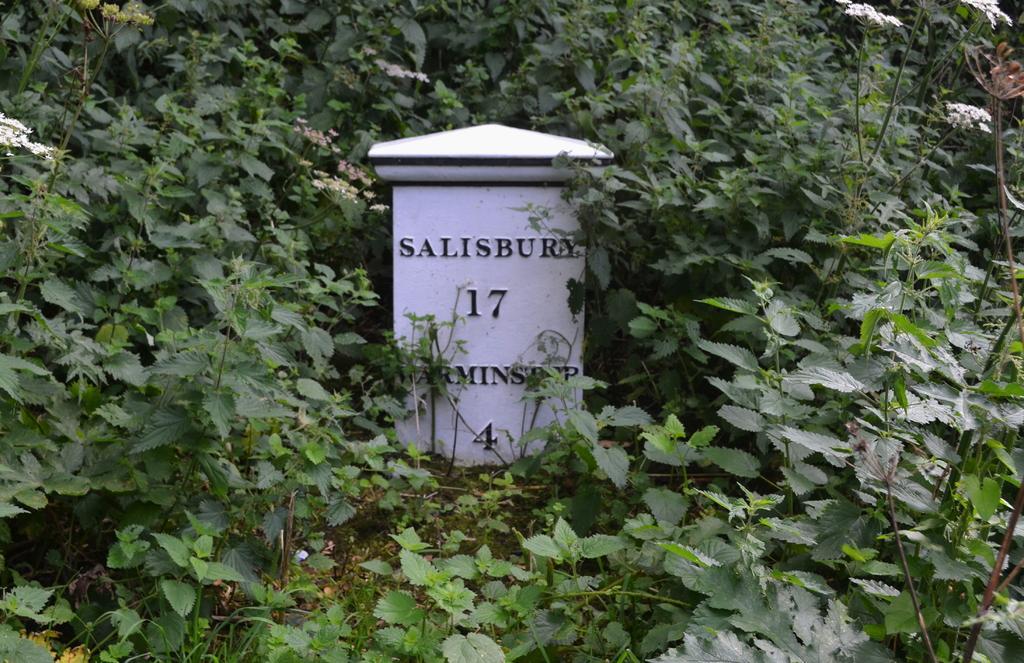How would you summarize this image in a sentence or two? In this image we can see many plants. We can see some text on the stone. 